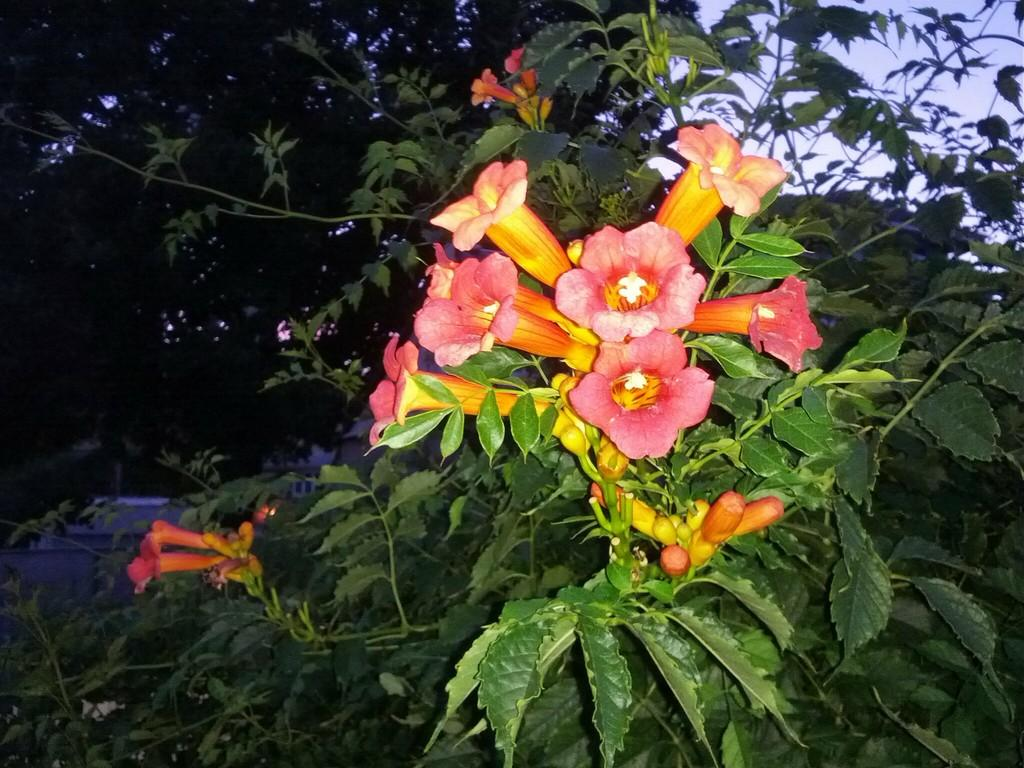What type of plant is visible in the image? There is a plant with flowers and buds in the image. What can be seen in the background of the image? There are trees and the sky visible in the background of the image. How does the straw interact with the plant in the image? There is no straw present in the image, so it cannot interact with the plant. 